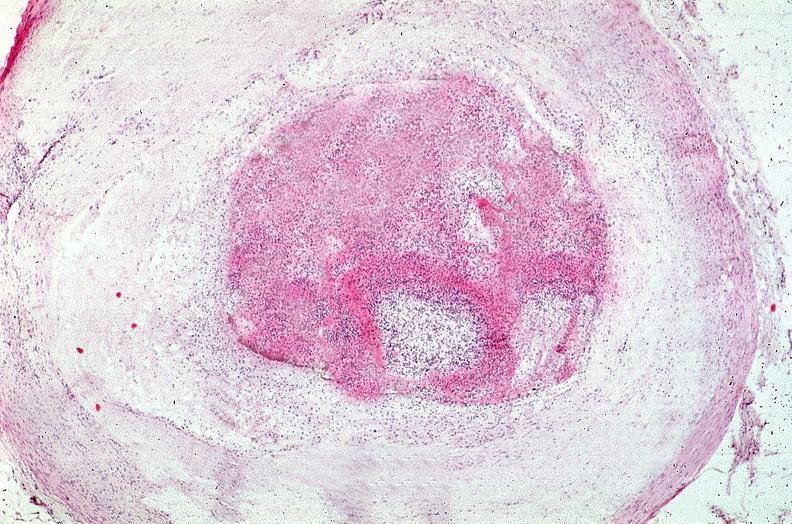what does this image show?
Answer the question using a single word or phrase. Coronary artery with atherosclerosis and thrombotic occlusion 